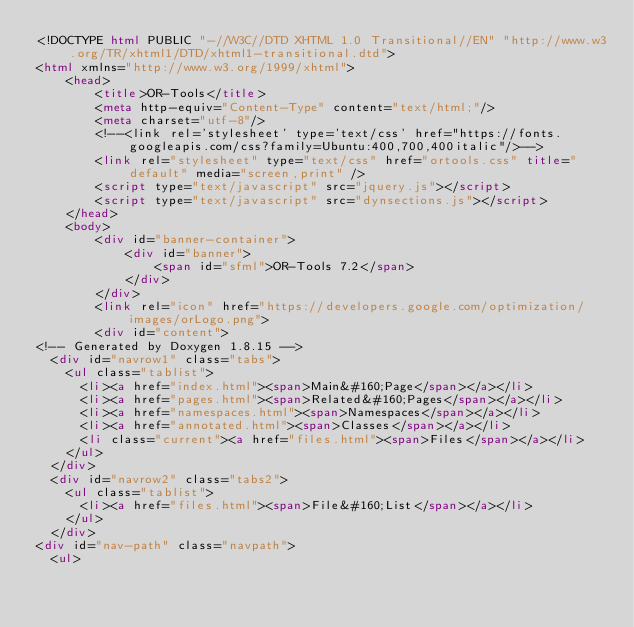<code> <loc_0><loc_0><loc_500><loc_500><_HTML_><!DOCTYPE html PUBLIC "-//W3C//DTD XHTML 1.0 Transitional//EN" "http://www.w3.org/TR/xhtml1/DTD/xhtml1-transitional.dtd">
<html xmlns="http://www.w3.org/1999/xhtml">
    <head>
        <title>OR-Tools</title>
        <meta http-equiv="Content-Type" content="text/html;"/>
        <meta charset="utf-8"/>
        <!--<link rel='stylesheet' type='text/css' href="https://fonts.googleapis.com/css?family=Ubuntu:400,700,400italic"/>-->
        <link rel="stylesheet" type="text/css" href="ortools.css" title="default" media="screen,print" />
        <script type="text/javascript" src="jquery.js"></script>
        <script type="text/javascript" src="dynsections.js"></script>
    </head>
    <body>
        <div id="banner-container">
            <div id="banner">
                <span id="sfml">OR-Tools 7.2</span>
            </div>
        </div>
        <link rel="icon" href="https://developers.google.com/optimization/images/orLogo.png">
        <div id="content">
<!-- Generated by Doxygen 1.8.15 -->
  <div id="navrow1" class="tabs">
    <ul class="tablist">
      <li><a href="index.html"><span>Main&#160;Page</span></a></li>
      <li><a href="pages.html"><span>Related&#160;Pages</span></a></li>
      <li><a href="namespaces.html"><span>Namespaces</span></a></li>
      <li><a href="annotated.html"><span>Classes</span></a></li>
      <li class="current"><a href="files.html"><span>Files</span></a></li>
    </ul>
  </div>
  <div id="navrow2" class="tabs2">
    <ul class="tablist">
      <li><a href="files.html"><span>File&#160;List</span></a></li>
    </ul>
  </div>
<div id="nav-path" class="navpath">
  <ul></code> 